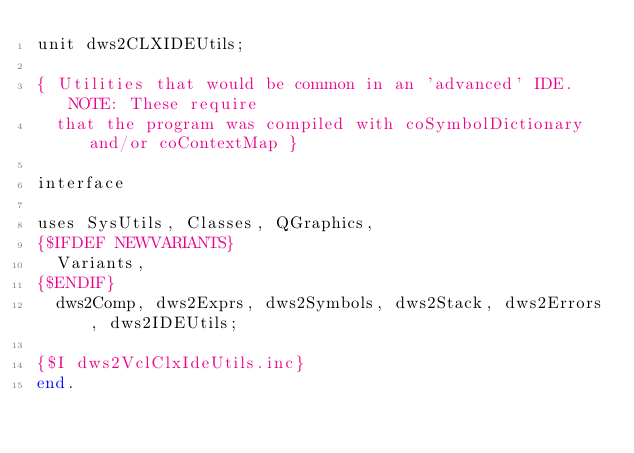Convert code to text. <code><loc_0><loc_0><loc_500><loc_500><_Pascal_>unit dws2CLXIDEUtils;

{ Utilities that would be common in an 'advanced' IDE. NOTE: These require
  that the program was compiled with coSymbolDictionary and/or coContextMap }

interface

uses SysUtils, Classes, QGraphics,
{$IFDEF NEWVARIANTS}
  Variants,
{$ENDIF}
  dws2Comp, dws2Exprs, dws2Symbols, dws2Stack, dws2Errors, dws2IDEUtils;

{$I dws2VclClxIdeUtils.inc}  
end.
</code> 